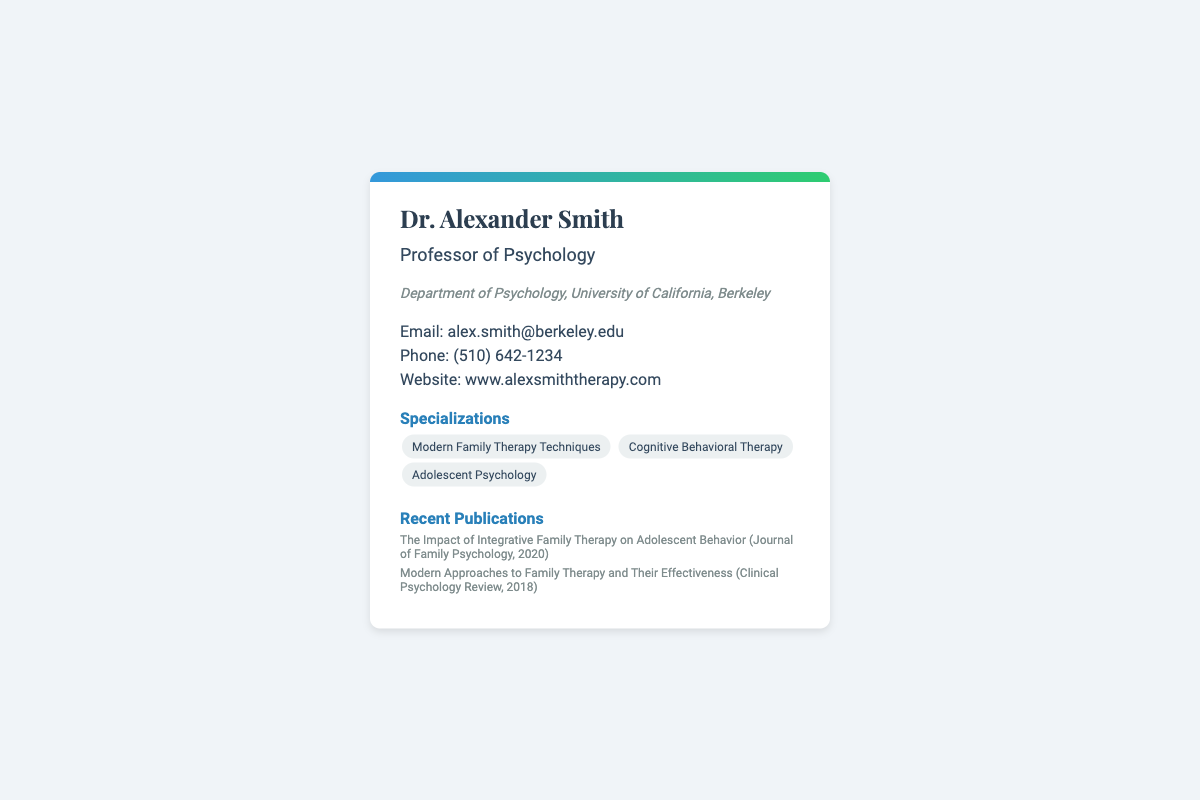What is the name of the author? The author's name is mentioned at the top of the business card as Dr. Alexander Smith.
Answer: Dr. Alexander Smith What is the author's position? The author's position is indicated under their name as Professor of Psychology.
Answer: Professor of Psychology Where is the author affiliated? The author's affiliation is stated in the business card as the Department of Psychology, University of California, Berkeley.
Answer: University of California, Berkeley What is the author's email address? The email address is provided in the contact section of the card as alex.smith@berkeley.edu.
Answer: alex.smith@berkeley.edu Which therapy technique is highlighted in the specializations? The specializations section lists Modern Family Therapy Techniques as one of the key areas of expertise.
Answer: Modern Family Therapy Techniques How many recent publications are listed? The number of publications can be counted from the publications section of the card, which has two entries.
Answer: 2 What is one of the recent publication titles? The titles are listed in the publications section, one of which is The Impact of Integrative Family Therapy on Adolescent Behavior.
Answer: The Impact of Integrative Family Therapy on Adolescent Behavior What is the author's phone number? The author's phone number is mentioned in the contact section as (510) 642-1234.
Answer: (510) 642-1234 What is the author's website? The website is provided in the contact information as www.alexsmiththerapy.com.
Answer: www.alexsmiththerapy.com 